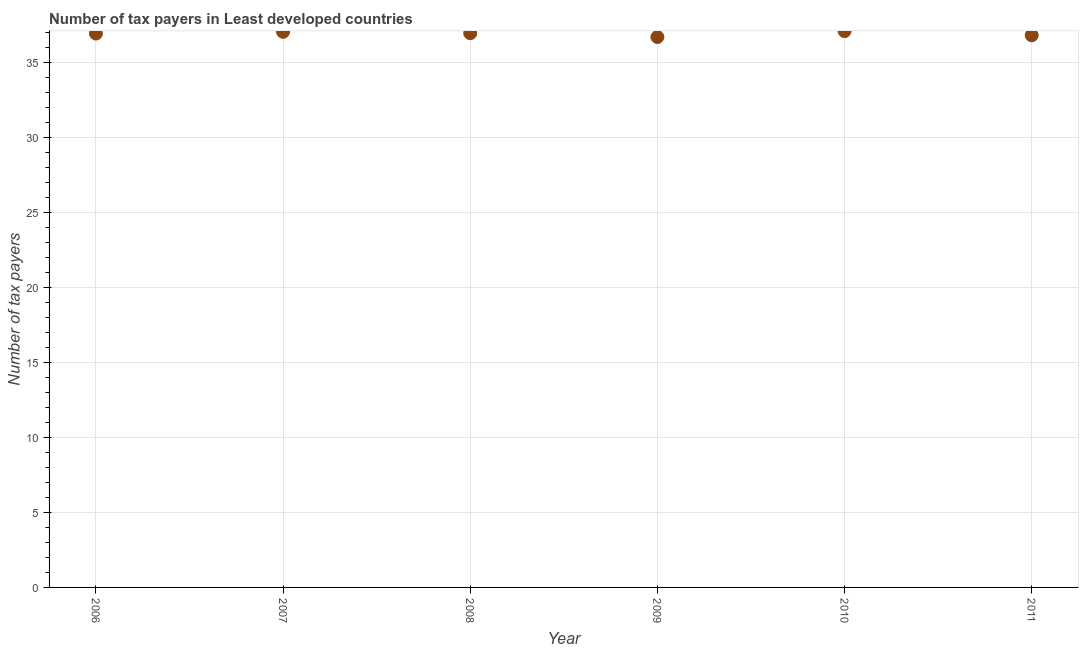What is the number of tax payers in 2006?
Your response must be concise. 36.91. Across all years, what is the maximum number of tax payers?
Offer a terse response. 37.07. Across all years, what is the minimum number of tax payers?
Your answer should be compact. 36.67. What is the sum of the number of tax payers?
Your answer should be compact. 221.4. What is the difference between the number of tax payers in 2007 and 2009?
Your answer should be very brief. 0.35. What is the average number of tax payers per year?
Offer a very short reply. 36.9. What is the median number of tax payers?
Your answer should be compact. 36.92. Do a majority of the years between 2009 and 2011 (inclusive) have number of tax payers greater than 18 ?
Provide a short and direct response. Yes. What is the ratio of the number of tax payers in 2006 to that in 2007?
Your response must be concise. 1. What is the difference between the highest and the second highest number of tax payers?
Offer a very short reply. 0.05. What is the difference between the highest and the lowest number of tax payers?
Give a very brief answer. 0.4. Does the number of tax payers monotonically increase over the years?
Keep it short and to the point. No. What is the difference between two consecutive major ticks on the Y-axis?
Make the answer very short. 5. Are the values on the major ticks of Y-axis written in scientific E-notation?
Offer a very short reply. No. What is the title of the graph?
Ensure brevity in your answer.  Number of tax payers in Least developed countries. What is the label or title of the Y-axis?
Offer a very short reply. Number of tax payers. What is the Number of tax payers in 2006?
Offer a very short reply. 36.91. What is the Number of tax payers in 2007?
Offer a very short reply. 37.02. What is the Number of tax payers in 2008?
Ensure brevity in your answer.  36.93. What is the Number of tax payers in 2009?
Keep it short and to the point. 36.67. What is the Number of tax payers in 2010?
Offer a very short reply. 37.07. What is the Number of tax payers in 2011?
Offer a very short reply. 36.79. What is the difference between the Number of tax payers in 2006 and 2007?
Offer a terse response. -0.12. What is the difference between the Number of tax payers in 2006 and 2008?
Provide a short and direct response. -0.02. What is the difference between the Number of tax payers in 2006 and 2009?
Make the answer very short. 0.23. What is the difference between the Number of tax payers in 2006 and 2010?
Keep it short and to the point. -0.16. What is the difference between the Number of tax payers in 2006 and 2011?
Keep it short and to the point. 0.12. What is the difference between the Number of tax payers in 2007 and 2008?
Provide a succinct answer. 0.09. What is the difference between the Number of tax payers in 2007 and 2009?
Your answer should be compact. 0.35. What is the difference between the Number of tax payers in 2007 and 2010?
Offer a terse response. -0.05. What is the difference between the Number of tax payers in 2007 and 2011?
Provide a succinct answer. 0.23. What is the difference between the Number of tax payers in 2008 and 2009?
Ensure brevity in your answer.  0.26. What is the difference between the Number of tax payers in 2008 and 2010?
Give a very brief answer. -0.14. What is the difference between the Number of tax payers in 2008 and 2011?
Your answer should be compact. 0.14. What is the difference between the Number of tax payers in 2009 and 2010?
Keep it short and to the point. -0.4. What is the difference between the Number of tax payers in 2009 and 2011?
Offer a very short reply. -0.12. What is the difference between the Number of tax payers in 2010 and 2011?
Provide a short and direct response. 0.28. What is the ratio of the Number of tax payers in 2006 to that in 2007?
Keep it short and to the point. 1. What is the ratio of the Number of tax payers in 2006 to that in 2009?
Offer a terse response. 1.01. What is the ratio of the Number of tax payers in 2006 to that in 2011?
Keep it short and to the point. 1. What is the ratio of the Number of tax payers in 2007 to that in 2008?
Offer a very short reply. 1. What is the ratio of the Number of tax payers in 2007 to that in 2009?
Give a very brief answer. 1.01. What is the ratio of the Number of tax payers in 2008 to that in 2011?
Your response must be concise. 1. What is the ratio of the Number of tax payers in 2009 to that in 2011?
Your response must be concise. 1. What is the ratio of the Number of tax payers in 2010 to that in 2011?
Your answer should be very brief. 1.01. 